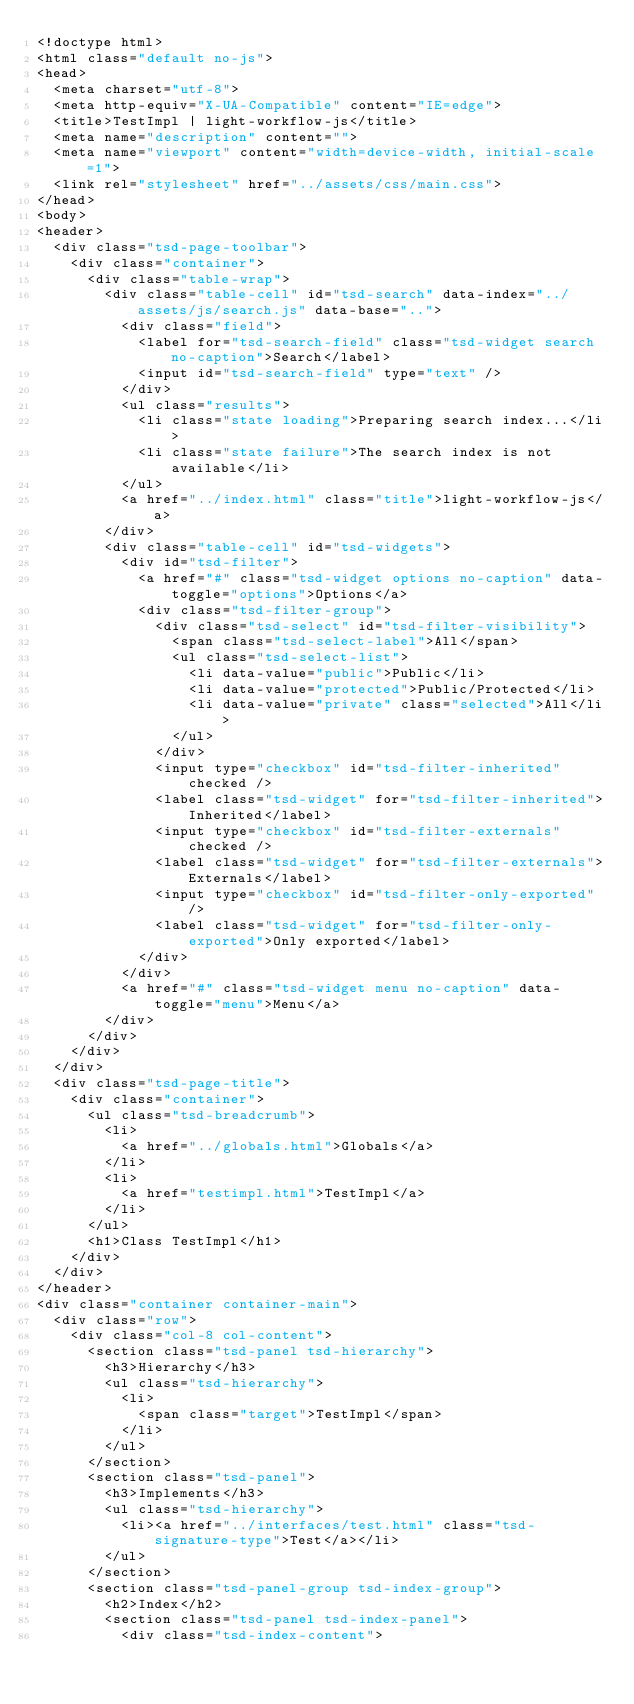Convert code to text. <code><loc_0><loc_0><loc_500><loc_500><_HTML_><!doctype html>
<html class="default no-js">
<head>
	<meta charset="utf-8">
	<meta http-equiv="X-UA-Compatible" content="IE=edge">
	<title>TestImpl | light-workflow-js</title>
	<meta name="description" content="">
	<meta name="viewport" content="width=device-width, initial-scale=1">
	<link rel="stylesheet" href="../assets/css/main.css">
</head>
<body>
<header>
	<div class="tsd-page-toolbar">
		<div class="container">
			<div class="table-wrap">
				<div class="table-cell" id="tsd-search" data-index="../assets/js/search.js" data-base="..">
					<div class="field">
						<label for="tsd-search-field" class="tsd-widget search no-caption">Search</label>
						<input id="tsd-search-field" type="text" />
					</div>
					<ul class="results">
						<li class="state loading">Preparing search index...</li>
						<li class="state failure">The search index is not available</li>
					</ul>
					<a href="../index.html" class="title">light-workflow-js</a>
				</div>
				<div class="table-cell" id="tsd-widgets">
					<div id="tsd-filter">
						<a href="#" class="tsd-widget options no-caption" data-toggle="options">Options</a>
						<div class="tsd-filter-group">
							<div class="tsd-select" id="tsd-filter-visibility">
								<span class="tsd-select-label">All</span>
								<ul class="tsd-select-list">
									<li data-value="public">Public</li>
									<li data-value="protected">Public/Protected</li>
									<li data-value="private" class="selected">All</li>
								</ul>
							</div>
							<input type="checkbox" id="tsd-filter-inherited" checked />
							<label class="tsd-widget" for="tsd-filter-inherited">Inherited</label>
							<input type="checkbox" id="tsd-filter-externals" checked />
							<label class="tsd-widget" for="tsd-filter-externals">Externals</label>
							<input type="checkbox" id="tsd-filter-only-exported" />
							<label class="tsd-widget" for="tsd-filter-only-exported">Only exported</label>
						</div>
					</div>
					<a href="#" class="tsd-widget menu no-caption" data-toggle="menu">Menu</a>
				</div>
			</div>
		</div>
	</div>
	<div class="tsd-page-title">
		<div class="container">
			<ul class="tsd-breadcrumb">
				<li>
					<a href="../globals.html">Globals</a>
				</li>
				<li>
					<a href="testimpl.html">TestImpl</a>
				</li>
			</ul>
			<h1>Class TestImpl</h1>
		</div>
	</div>
</header>
<div class="container container-main">
	<div class="row">
		<div class="col-8 col-content">
			<section class="tsd-panel tsd-hierarchy">
				<h3>Hierarchy</h3>
				<ul class="tsd-hierarchy">
					<li>
						<span class="target">TestImpl</span>
					</li>
				</ul>
			</section>
			<section class="tsd-panel">
				<h3>Implements</h3>
				<ul class="tsd-hierarchy">
					<li><a href="../interfaces/test.html" class="tsd-signature-type">Test</a></li>
				</ul>
			</section>
			<section class="tsd-panel-group tsd-index-group">
				<h2>Index</h2>
				<section class="tsd-panel tsd-index-panel">
					<div class="tsd-index-content"></code> 